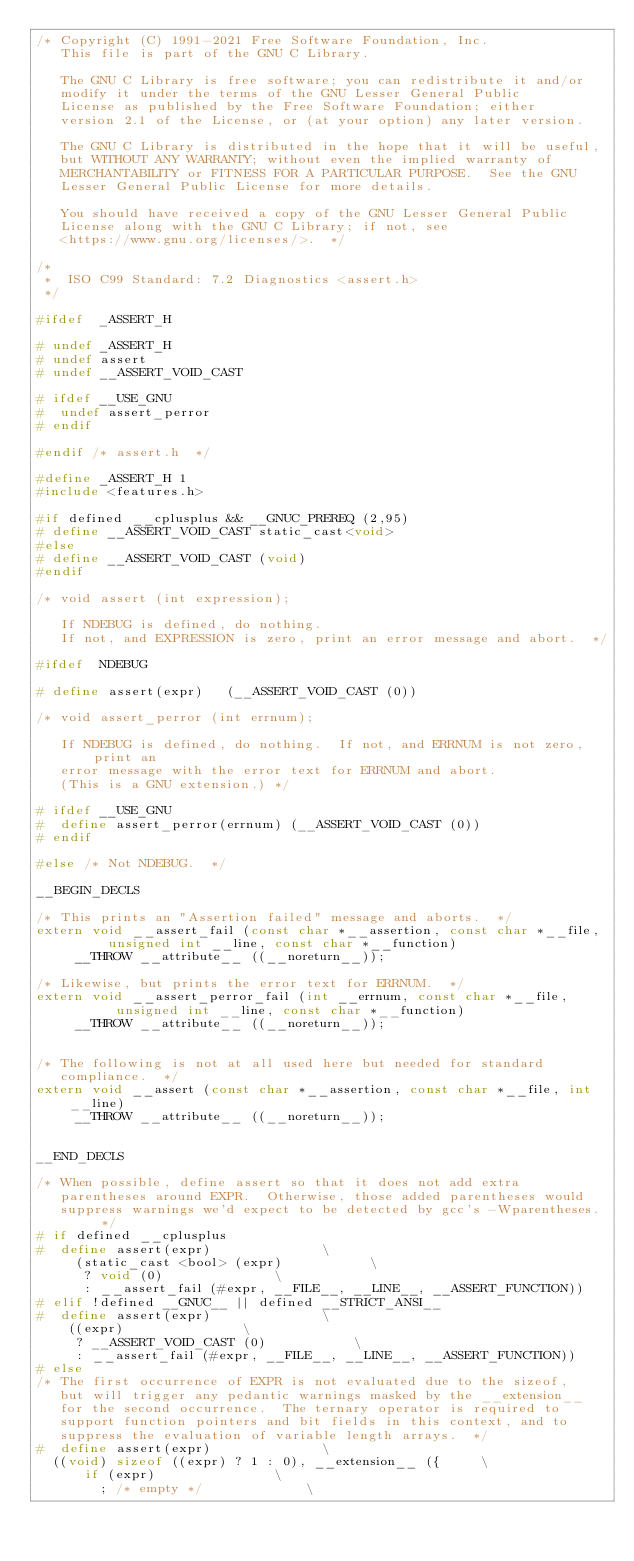<code> <loc_0><loc_0><loc_500><loc_500><_C_>/* Copyright (C) 1991-2021 Free Software Foundation, Inc.
   This file is part of the GNU C Library.

   The GNU C Library is free software; you can redistribute it and/or
   modify it under the terms of the GNU Lesser General Public
   License as published by the Free Software Foundation; either
   version 2.1 of the License, or (at your option) any later version.

   The GNU C Library is distributed in the hope that it will be useful,
   but WITHOUT ANY WARRANTY; without even the implied warranty of
   MERCHANTABILITY or FITNESS FOR A PARTICULAR PURPOSE.  See the GNU
   Lesser General Public License for more details.

   You should have received a copy of the GNU Lesser General Public
   License along with the GNU C Library; if not, see
   <https://www.gnu.org/licenses/>.  */

/*
 *	ISO C99 Standard: 7.2 Diagnostics	<assert.h>
 */

#ifdef	_ASSERT_H

# undef	_ASSERT_H
# undef	assert
# undef __ASSERT_VOID_CAST

# ifdef	__USE_GNU
#  undef assert_perror
# endif

#endif /* assert.h	*/

#define	_ASSERT_H	1
#include <features.h>

#if defined __cplusplus && __GNUC_PREREQ (2,95)
# define __ASSERT_VOID_CAST static_cast<void>
#else
# define __ASSERT_VOID_CAST (void)
#endif

/* void assert (int expression);

   If NDEBUG is defined, do nothing.
   If not, and EXPRESSION is zero, print an error message and abort.  */

#ifdef	NDEBUG

# define assert(expr)		(__ASSERT_VOID_CAST (0))

/* void assert_perror (int errnum);

   If NDEBUG is defined, do nothing.  If not, and ERRNUM is not zero, print an
   error message with the error text for ERRNUM and abort.
   (This is a GNU extension.) */

# ifdef	__USE_GNU
#  define assert_perror(errnum)	(__ASSERT_VOID_CAST (0))
# endif

#else /* Not NDEBUG.  */

__BEGIN_DECLS

/* This prints an "Assertion failed" message and aborts.  */
extern void __assert_fail (const char *__assertion, const char *__file,
			   unsigned int __line, const char *__function)
     __THROW __attribute__ ((__noreturn__));

/* Likewise, but prints the error text for ERRNUM.  */
extern void __assert_perror_fail (int __errnum, const char *__file,
				  unsigned int __line, const char *__function)
     __THROW __attribute__ ((__noreturn__));


/* The following is not at all used here but needed for standard
   compliance.  */
extern void __assert (const char *__assertion, const char *__file, int __line)
     __THROW __attribute__ ((__noreturn__));


__END_DECLS

/* When possible, define assert so that it does not add extra
   parentheses around EXPR.  Otherwise, those added parentheses would
   suppress warnings we'd expect to be detected by gcc's -Wparentheses.  */
# if defined __cplusplus
#  define assert(expr)							\
     (static_cast <bool> (expr)						\
      ? void (0)							\
      : __assert_fail (#expr, __FILE__, __LINE__, __ASSERT_FUNCTION))
# elif !defined __GNUC__ || defined __STRICT_ANSI__
#  define assert(expr)							\
    ((expr)								\
     ? __ASSERT_VOID_CAST (0)						\
     : __assert_fail (#expr, __FILE__, __LINE__, __ASSERT_FUNCTION))
# else
/* The first occurrence of EXPR is not evaluated due to the sizeof,
   but will trigger any pedantic warnings masked by the __extension__
   for the second occurrence.  The ternary operator is required to
   support function pointers and bit fields in this context, and to
   suppress the evaluation of variable length arrays.  */
#  define assert(expr)							\
  ((void) sizeof ((expr) ? 1 : 0), __extension__ ({			\
      if (expr)								\
        ; /* empty */							\</code> 